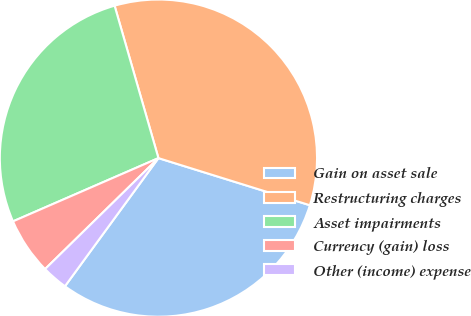Convert chart. <chart><loc_0><loc_0><loc_500><loc_500><pie_chart><fcel>Gain on asset sale<fcel>Restructuring charges<fcel>Asset impairments<fcel>Currency (gain) loss<fcel>Other (income) expense<nl><fcel>30.23%<fcel>34.26%<fcel>27.07%<fcel>5.8%<fcel>2.64%<nl></chart> 